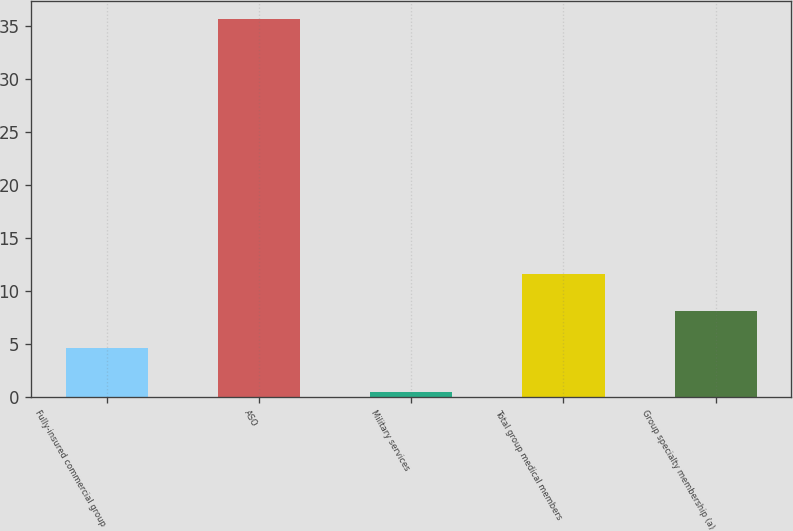Convert chart to OTSL. <chart><loc_0><loc_0><loc_500><loc_500><bar_chart><fcel>Fully-insured commercial group<fcel>ASO<fcel>Military services<fcel>Total group medical members<fcel>Group specialty membership (a)<nl><fcel>4.6<fcel>35.6<fcel>0.5<fcel>11.62<fcel>8.11<nl></chart> 